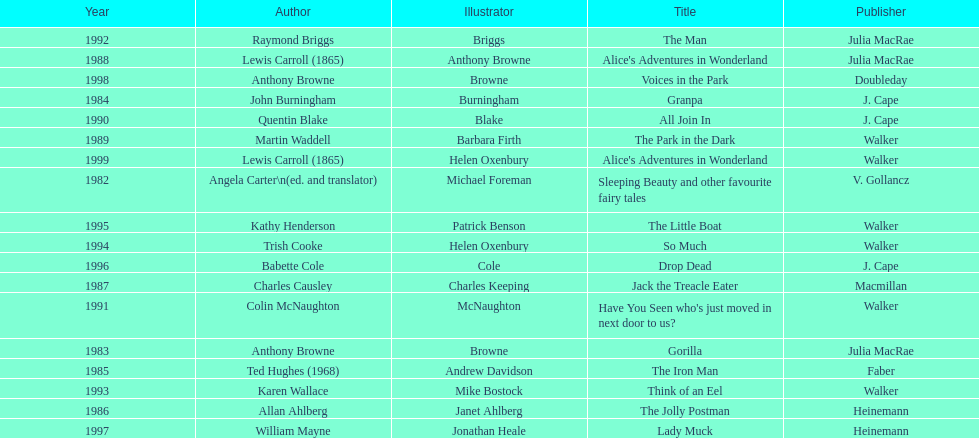What is the only title listed for 1999? Alice's Adventures in Wonderland. 